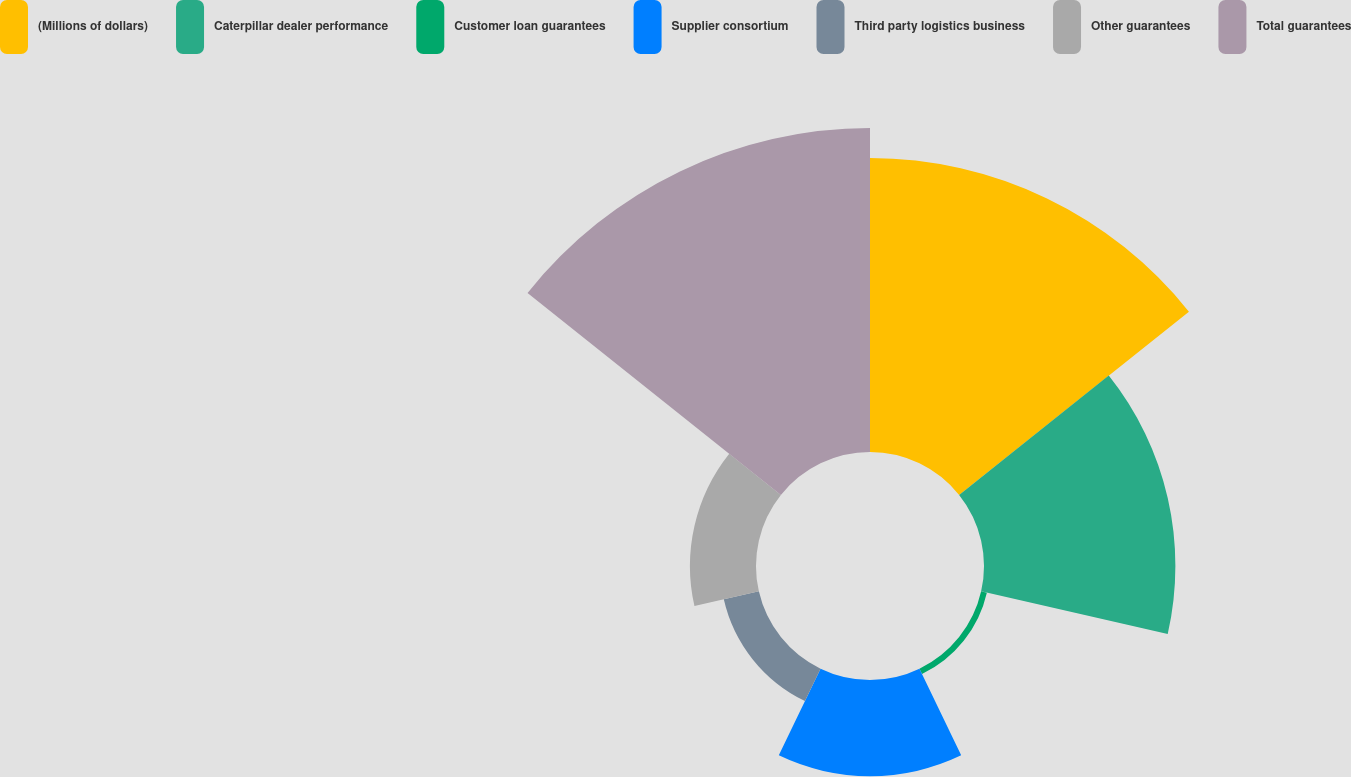Convert chart to OTSL. <chart><loc_0><loc_0><loc_500><loc_500><pie_chart><fcel>(Millions of dollars)<fcel>Caterpillar dealer performance<fcel>Customer loan guarantees<fcel>Supplier consortium<fcel>Third party logistics business<fcel>Other guarantees<fcel>Total guarantees<nl><fcel>29.01%<fcel>18.89%<fcel>0.58%<fcel>9.49%<fcel>3.55%<fcel>6.52%<fcel>31.98%<nl></chart> 